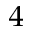Convert formula to latex. <formula><loc_0><loc_0><loc_500><loc_500>^ { 4 }</formula> 